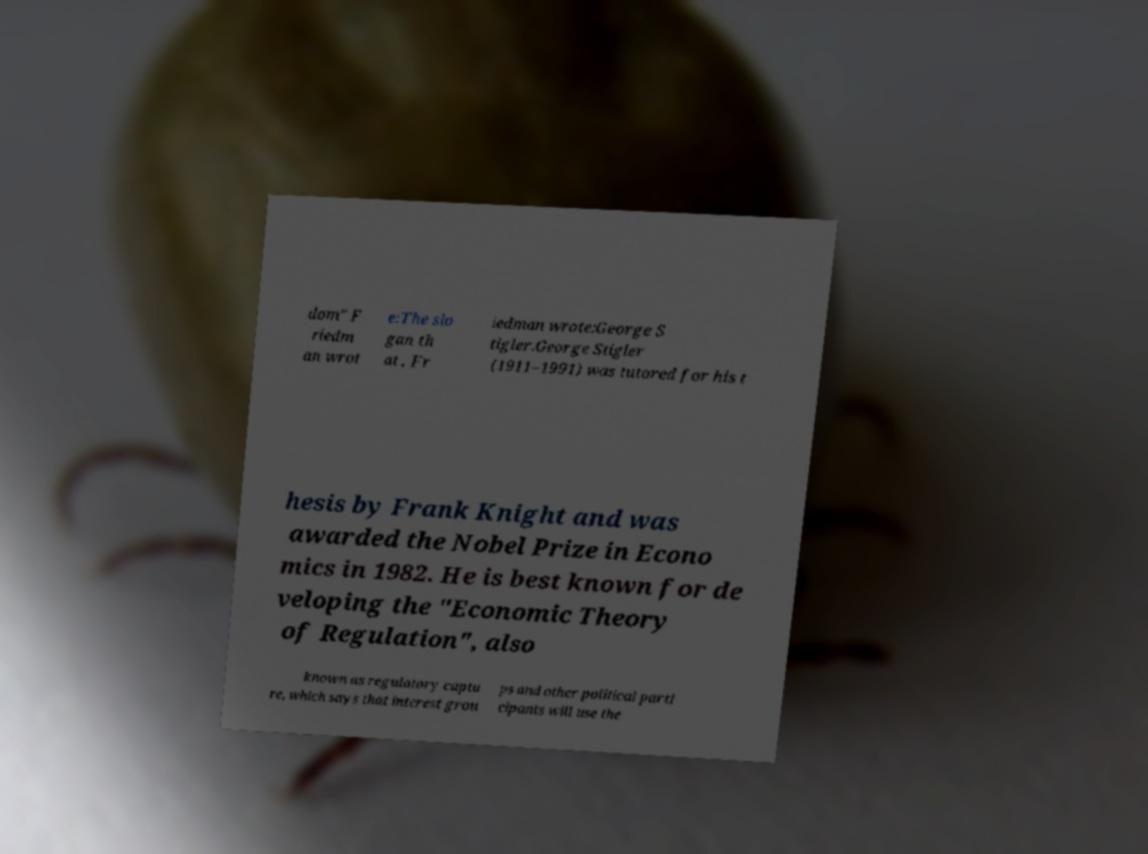For documentation purposes, I need the text within this image transcribed. Could you provide that? dom" F riedm an wrot e:The slo gan th at , Fr iedman wrote:George S tigler.George Stigler (1911–1991) was tutored for his t hesis by Frank Knight and was awarded the Nobel Prize in Econo mics in 1982. He is best known for de veloping the "Economic Theory of Regulation", also known as regulatory captu re, which says that interest grou ps and other political parti cipants will use the 